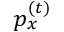<formula> <loc_0><loc_0><loc_500><loc_500>p _ { x } ^ { ( t ) }</formula> 